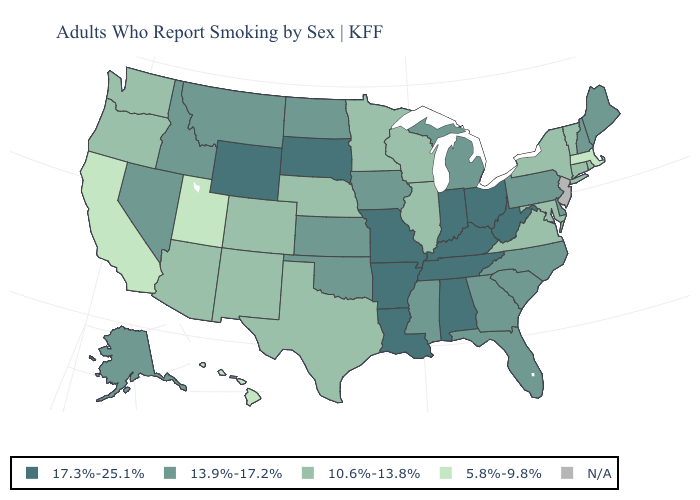Name the states that have a value in the range N/A?
Keep it brief. New Jersey. What is the value of North Carolina?
Quick response, please. 13.9%-17.2%. Name the states that have a value in the range N/A?
Give a very brief answer. New Jersey. Name the states that have a value in the range 10.6%-13.8%?
Give a very brief answer. Arizona, Colorado, Connecticut, Illinois, Maryland, Minnesota, Nebraska, New Mexico, New York, Oregon, Rhode Island, Texas, Vermont, Virginia, Washington, Wisconsin. What is the highest value in the Northeast ?
Short answer required. 13.9%-17.2%. Name the states that have a value in the range 17.3%-25.1%?
Give a very brief answer. Alabama, Arkansas, Indiana, Kentucky, Louisiana, Missouri, Ohio, South Dakota, Tennessee, West Virginia, Wyoming. What is the value of Michigan?
Short answer required. 13.9%-17.2%. What is the lowest value in the Northeast?
Write a very short answer. 5.8%-9.8%. Which states have the lowest value in the Northeast?
Give a very brief answer. Massachusetts. What is the value of Alaska?
Write a very short answer. 13.9%-17.2%. Which states hav the highest value in the Northeast?
Answer briefly. Maine, New Hampshire, Pennsylvania. What is the lowest value in states that border Massachusetts?
Concise answer only. 10.6%-13.8%. Name the states that have a value in the range N/A?
Be succinct. New Jersey. Does the map have missing data?
Be succinct. Yes. 